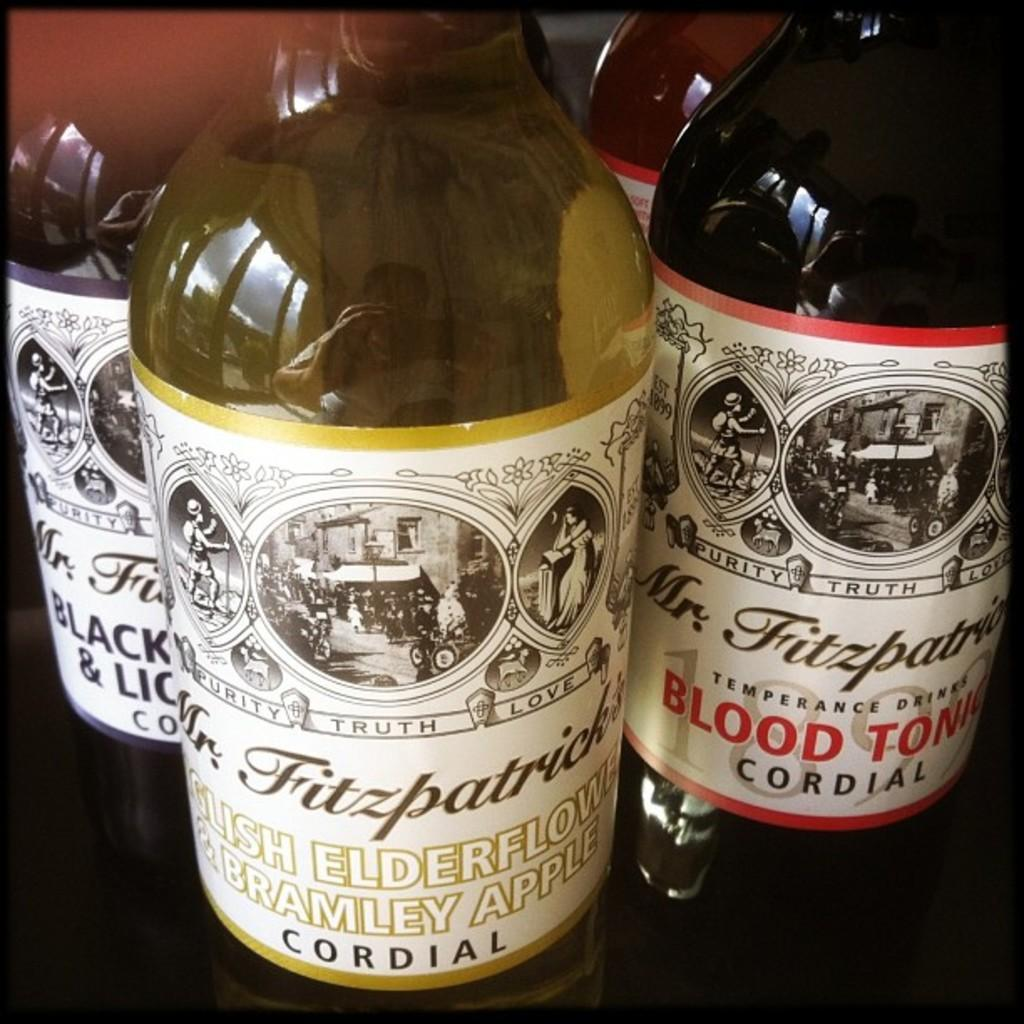Provide a one-sentence caption for the provided image. Four bottles of Mr. Fitzpatrick's Cordial are being displayed next to each other. 